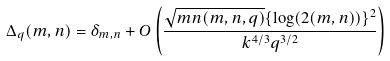Convert formula to latex. <formula><loc_0><loc_0><loc_500><loc_500>\Delta _ { q } ( m , n ) = \delta _ { m , n } + O \left ( \frac { \sqrt { m n ( m , n , q ) } \{ \log ( 2 ( m , n ) ) \} ^ { 2 } } { k ^ { 4 / 3 } q ^ { 3 / 2 } } \right )</formula> 